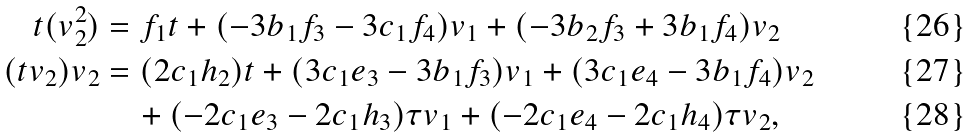Convert formula to latex. <formula><loc_0><loc_0><loc_500><loc_500>t ( v _ { 2 } ^ { 2 } ) & = f _ { 1 } t + ( - 3 b _ { 1 } f _ { 3 } - 3 c _ { 1 } f _ { 4 } ) v _ { 1 } + ( - 3 b _ { 2 } f _ { 3 } + 3 b _ { 1 } f _ { 4 } ) v _ { 2 } \\ ( t v _ { 2 } ) v _ { 2 } & = ( 2 c _ { 1 } h _ { 2 } ) t + ( 3 c _ { 1 } e _ { 3 } - 3 b _ { 1 } f _ { 3 } ) v _ { 1 } + ( 3 c _ { 1 } e _ { 4 } - 3 b _ { 1 } f _ { 4 } ) v _ { 2 } \\ & \quad + ( - 2 c _ { 1 } e _ { 3 } - 2 c _ { 1 } h _ { 3 } ) \tau v _ { 1 } + ( - 2 c _ { 1 } e _ { 4 } - 2 c _ { 1 } h _ { 4 } ) \tau v _ { 2 } ,</formula> 